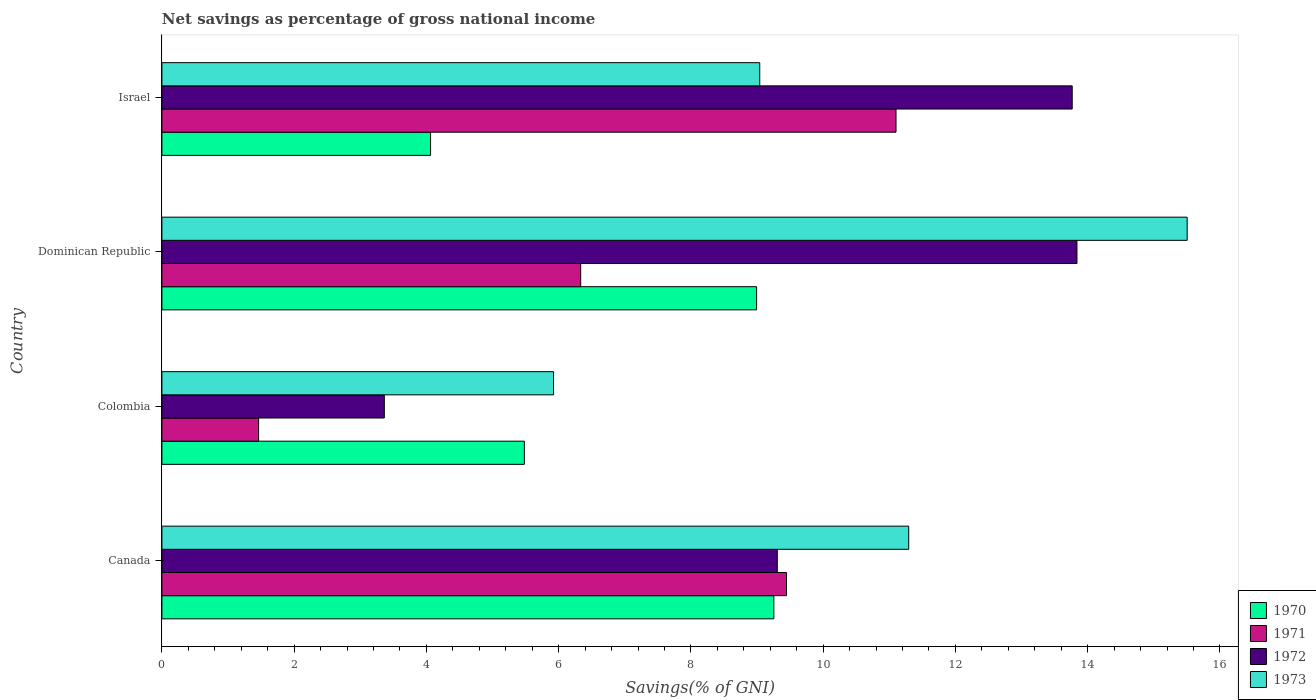How many different coloured bars are there?
Give a very brief answer. 4. How many groups of bars are there?
Give a very brief answer. 4. What is the label of the 4th group of bars from the top?
Keep it short and to the point. Canada. In how many cases, is the number of bars for a given country not equal to the number of legend labels?
Make the answer very short. 0. What is the total savings in 1971 in Canada?
Your response must be concise. 9.45. Across all countries, what is the maximum total savings in 1970?
Offer a terse response. 9.25. Across all countries, what is the minimum total savings in 1971?
Provide a succinct answer. 1.46. In which country was the total savings in 1970 maximum?
Your answer should be very brief. Canada. In which country was the total savings in 1970 minimum?
Offer a very short reply. Israel. What is the total total savings in 1970 in the graph?
Give a very brief answer. 27.79. What is the difference between the total savings in 1972 in Canada and that in Israel?
Provide a succinct answer. -4.46. What is the difference between the total savings in 1970 in Colombia and the total savings in 1971 in Canada?
Offer a very short reply. -3.96. What is the average total savings in 1971 per country?
Your response must be concise. 7.09. What is the difference between the total savings in 1972 and total savings in 1971 in Colombia?
Provide a short and direct response. 1.9. In how many countries, is the total savings in 1973 greater than 11.6 %?
Offer a very short reply. 1. What is the ratio of the total savings in 1973 in Canada to that in Israel?
Make the answer very short. 1.25. Is the total savings in 1972 in Canada less than that in Israel?
Make the answer very short. Yes. Is the difference between the total savings in 1972 in Canada and Dominican Republic greater than the difference between the total savings in 1971 in Canada and Dominican Republic?
Ensure brevity in your answer.  No. What is the difference between the highest and the second highest total savings in 1972?
Give a very brief answer. 0.07. What is the difference between the highest and the lowest total savings in 1971?
Your answer should be very brief. 9.64. In how many countries, is the total savings in 1972 greater than the average total savings in 1972 taken over all countries?
Keep it short and to the point. 2. Is the sum of the total savings in 1973 in Canada and Israel greater than the maximum total savings in 1971 across all countries?
Offer a terse response. Yes. What does the 3rd bar from the top in Canada represents?
Offer a very short reply. 1971. What does the 1st bar from the bottom in Colombia represents?
Provide a short and direct response. 1970. How many bars are there?
Provide a succinct answer. 16. How many countries are there in the graph?
Ensure brevity in your answer.  4. Are the values on the major ticks of X-axis written in scientific E-notation?
Keep it short and to the point. No. Does the graph contain any zero values?
Provide a short and direct response. No. Where does the legend appear in the graph?
Ensure brevity in your answer.  Bottom right. What is the title of the graph?
Provide a succinct answer. Net savings as percentage of gross national income. What is the label or title of the X-axis?
Your answer should be very brief. Savings(% of GNI). What is the Savings(% of GNI) in 1970 in Canada?
Offer a very short reply. 9.25. What is the Savings(% of GNI) of 1971 in Canada?
Offer a very short reply. 9.45. What is the Savings(% of GNI) of 1972 in Canada?
Provide a short and direct response. 9.31. What is the Savings(% of GNI) of 1973 in Canada?
Offer a very short reply. 11.29. What is the Savings(% of GNI) in 1970 in Colombia?
Offer a very short reply. 5.48. What is the Savings(% of GNI) of 1971 in Colombia?
Offer a very short reply. 1.46. What is the Savings(% of GNI) of 1972 in Colombia?
Give a very brief answer. 3.36. What is the Savings(% of GNI) in 1973 in Colombia?
Your answer should be compact. 5.92. What is the Savings(% of GNI) in 1970 in Dominican Republic?
Ensure brevity in your answer.  8.99. What is the Savings(% of GNI) of 1971 in Dominican Republic?
Provide a succinct answer. 6.33. What is the Savings(% of GNI) in 1972 in Dominican Republic?
Ensure brevity in your answer.  13.84. What is the Savings(% of GNI) in 1973 in Dominican Republic?
Offer a very short reply. 15.5. What is the Savings(% of GNI) in 1970 in Israel?
Offer a very short reply. 4.06. What is the Savings(% of GNI) of 1971 in Israel?
Your answer should be very brief. 11.1. What is the Savings(% of GNI) in 1972 in Israel?
Provide a succinct answer. 13.77. What is the Savings(% of GNI) in 1973 in Israel?
Offer a very short reply. 9.04. Across all countries, what is the maximum Savings(% of GNI) of 1970?
Your answer should be very brief. 9.25. Across all countries, what is the maximum Savings(% of GNI) of 1971?
Keep it short and to the point. 11.1. Across all countries, what is the maximum Savings(% of GNI) of 1972?
Your answer should be compact. 13.84. Across all countries, what is the maximum Savings(% of GNI) of 1973?
Provide a succinct answer. 15.5. Across all countries, what is the minimum Savings(% of GNI) of 1970?
Your response must be concise. 4.06. Across all countries, what is the minimum Savings(% of GNI) in 1971?
Your response must be concise. 1.46. Across all countries, what is the minimum Savings(% of GNI) of 1972?
Keep it short and to the point. 3.36. Across all countries, what is the minimum Savings(% of GNI) in 1973?
Offer a terse response. 5.92. What is the total Savings(% of GNI) in 1970 in the graph?
Make the answer very short. 27.79. What is the total Savings(% of GNI) of 1971 in the graph?
Give a very brief answer. 28.34. What is the total Savings(% of GNI) in 1972 in the graph?
Keep it short and to the point. 40.27. What is the total Savings(% of GNI) in 1973 in the graph?
Ensure brevity in your answer.  41.76. What is the difference between the Savings(% of GNI) in 1970 in Canada and that in Colombia?
Your answer should be very brief. 3.77. What is the difference between the Savings(% of GNI) of 1971 in Canada and that in Colombia?
Keep it short and to the point. 7.98. What is the difference between the Savings(% of GNI) in 1972 in Canada and that in Colombia?
Your answer should be compact. 5.94. What is the difference between the Savings(% of GNI) in 1973 in Canada and that in Colombia?
Give a very brief answer. 5.37. What is the difference between the Savings(% of GNI) of 1970 in Canada and that in Dominican Republic?
Keep it short and to the point. 0.26. What is the difference between the Savings(% of GNI) of 1971 in Canada and that in Dominican Republic?
Provide a short and direct response. 3.11. What is the difference between the Savings(% of GNI) of 1972 in Canada and that in Dominican Republic?
Offer a terse response. -4.53. What is the difference between the Savings(% of GNI) of 1973 in Canada and that in Dominican Republic?
Make the answer very short. -4.21. What is the difference between the Savings(% of GNI) of 1970 in Canada and that in Israel?
Your answer should be very brief. 5.19. What is the difference between the Savings(% of GNI) of 1971 in Canada and that in Israel?
Give a very brief answer. -1.66. What is the difference between the Savings(% of GNI) in 1972 in Canada and that in Israel?
Offer a very short reply. -4.46. What is the difference between the Savings(% of GNI) of 1973 in Canada and that in Israel?
Offer a very short reply. 2.25. What is the difference between the Savings(% of GNI) of 1970 in Colombia and that in Dominican Republic?
Provide a succinct answer. -3.51. What is the difference between the Savings(% of GNI) of 1971 in Colombia and that in Dominican Republic?
Offer a terse response. -4.87. What is the difference between the Savings(% of GNI) of 1972 in Colombia and that in Dominican Republic?
Provide a short and direct response. -10.47. What is the difference between the Savings(% of GNI) in 1973 in Colombia and that in Dominican Republic?
Your answer should be very brief. -9.58. What is the difference between the Savings(% of GNI) of 1970 in Colombia and that in Israel?
Give a very brief answer. 1.42. What is the difference between the Savings(% of GNI) in 1971 in Colombia and that in Israel?
Offer a very short reply. -9.64. What is the difference between the Savings(% of GNI) in 1972 in Colombia and that in Israel?
Keep it short and to the point. -10.4. What is the difference between the Savings(% of GNI) in 1973 in Colombia and that in Israel?
Your answer should be very brief. -3.12. What is the difference between the Savings(% of GNI) of 1970 in Dominican Republic and that in Israel?
Make the answer very short. 4.93. What is the difference between the Savings(% of GNI) of 1971 in Dominican Republic and that in Israel?
Ensure brevity in your answer.  -4.77. What is the difference between the Savings(% of GNI) in 1972 in Dominican Republic and that in Israel?
Ensure brevity in your answer.  0.07. What is the difference between the Savings(% of GNI) of 1973 in Dominican Republic and that in Israel?
Offer a very short reply. 6.46. What is the difference between the Savings(% of GNI) in 1970 in Canada and the Savings(% of GNI) in 1971 in Colombia?
Offer a terse response. 7.79. What is the difference between the Savings(% of GNI) of 1970 in Canada and the Savings(% of GNI) of 1972 in Colombia?
Provide a succinct answer. 5.89. What is the difference between the Savings(% of GNI) of 1970 in Canada and the Savings(% of GNI) of 1973 in Colombia?
Give a very brief answer. 3.33. What is the difference between the Savings(% of GNI) in 1971 in Canada and the Savings(% of GNI) in 1972 in Colombia?
Your answer should be very brief. 6.08. What is the difference between the Savings(% of GNI) of 1971 in Canada and the Savings(% of GNI) of 1973 in Colombia?
Your answer should be compact. 3.52. What is the difference between the Savings(% of GNI) of 1972 in Canada and the Savings(% of GNI) of 1973 in Colombia?
Your response must be concise. 3.38. What is the difference between the Savings(% of GNI) in 1970 in Canada and the Savings(% of GNI) in 1971 in Dominican Republic?
Offer a very short reply. 2.92. What is the difference between the Savings(% of GNI) in 1970 in Canada and the Savings(% of GNI) in 1972 in Dominican Republic?
Ensure brevity in your answer.  -4.58. What is the difference between the Savings(% of GNI) of 1970 in Canada and the Savings(% of GNI) of 1973 in Dominican Republic?
Keep it short and to the point. -6.25. What is the difference between the Savings(% of GNI) in 1971 in Canada and the Savings(% of GNI) in 1972 in Dominican Republic?
Your answer should be very brief. -4.39. What is the difference between the Savings(% of GNI) in 1971 in Canada and the Savings(% of GNI) in 1973 in Dominican Republic?
Your answer should be very brief. -6.06. What is the difference between the Savings(% of GNI) in 1972 in Canada and the Savings(% of GNI) in 1973 in Dominican Republic?
Your answer should be compact. -6.2. What is the difference between the Savings(% of GNI) in 1970 in Canada and the Savings(% of GNI) in 1971 in Israel?
Your answer should be very brief. -1.85. What is the difference between the Savings(% of GNI) in 1970 in Canada and the Savings(% of GNI) in 1972 in Israel?
Keep it short and to the point. -4.51. What is the difference between the Savings(% of GNI) of 1970 in Canada and the Savings(% of GNI) of 1973 in Israel?
Your answer should be compact. 0.21. What is the difference between the Savings(% of GNI) in 1971 in Canada and the Savings(% of GNI) in 1972 in Israel?
Your response must be concise. -4.32. What is the difference between the Savings(% of GNI) of 1971 in Canada and the Savings(% of GNI) of 1973 in Israel?
Make the answer very short. 0.4. What is the difference between the Savings(% of GNI) in 1972 in Canada and the Savings(% of GNI) in 1973 in Israel?
Your answer should be very brief. 0.27. What is the difference between the Savings(% of GNI) in 1970 in Colombia and the Savings(% of GNI) in 1971 in Dominican Republic?
Your answer should be compact. -0.85. What is the difference between the Savings(% of GNI) of 1970 in Colombia and the Savings(% of GNI) of 1972 in Dominican Republic?
Offer a very short reply. -8.36. What is the difference between the Savings(% of GNI) of 1970 in Colombia and the Savings(% of GNI) of 1973 in Dominican Republic?
Ensure brevity in your answer.  -10.02. What is the difference between the Savings(% of GNI) in 1971 in Colombia and the Savings(% of GNI) in 1972 in Dominican Republic?
Make the answer very short. -12.38. What is the difference between the Savings(% of GNI) of 1971 in Colombia and the Savings(% of GNI) of 1973 in Dominican Republic?
Make the answer very short. -14.04. What is the difference between the Savings(% of GNI) of 1972 in Colombia and the Savings(% of GNI) of 1973 in Dominican Republic?
Ensure brevity in your answer.  -12.14. What is the difference between the Savings(% of GNI) of 1970 in Colombia and the Savings(% of GNI) of 1971 in Israel?
Give a very brief answer. -5.62. What is the difference between the Savings(% of GNI) of 1970 in Colombia and the Savings(% of GNI) of 1972 in Israel?
Ensure brevity in your answer.  -8.28. What is the difference between the Savings(% of GNI) in 1970 in Colombia and the Savings(% of GNI) in 1973 in Israel?
Make the answer very short. -3.56. What is the difference between the Savings(% of GNI) in 1971 in Colombia and the Savings(% of GNI) in 1972 in Israel?
Provide a succinct answer. -12.3. What is the difference between the Savings(% of GNI) of 1971 in Colombia and the Savings(% of GNI) of 1973 in Israel?
Provide a succinct answer. -7.58. What is the difference between the Savings(% of GNI) of 1972 in Colombia and the Savings(% of GNI) of 1973 in Israel?
Provide a short and direct response. -5.68. What is the difference between the Savings(% of GNI) in 1970 in Dominican Republic and the Savings(% of GNI) in 1971 in Israel?
Keep it short and to the point. -2.11. What is the difference between the Savings(% of GNI) in 1970 in Dominican Republic and the Savings(% of GNI) in 1972 in Israel?
Your response must be concise. -4.77. What is the difference between the Savings(% of GNI) of 1970 in Dominican Republic and the Savings(% of GNI) of 1973 in Israel?
Your answer should be compact. -0.05. What is the difference between the Savings(% of GNI) of 1971 in Dominican Republic and the Savings(% of GNI) of 1972 in Israel?
Provide a succinct answer. -7.43. What is the difference between the Savings(% of GNI) of 1971 in Dominican Republic and the Savings(% of GNI) of 1973 in Israel?
Your response must be concise. -2.71. What is the difference between the Savings(% of GNI) of 1972 in Dominican Republic and the Savings(% of GNI) of 1973 in Israel?
Offer a very short reply. 4.8. What is the average Savings(% of GNI) of 1970 per country?
Keep it short and to the point. 6.95. What is the average Savings(% of GNI) in 1971 per country?
Give a very brief answer. 7.09. What is the average Savings(% of GNI) in 1972 per country?
Keep it short and to the point. 10.07. What is the average Savings(% of GNI) in 1973 per country?
Ensure brevity in your answer.  10.44. What is the difference between the Savings(% of GNI) in 1970 and Savings(% of GNI) in 1971 in Canada?
Make the answer very short. -0.19. What is the difference between the Savings(% of GNI) of 1970 and Savings(% of GNI) of 1972 in Canada?
Ensure brevity in your answer.  -0.05. What is the difference between the Savings(% of GNI) in 1970 and Savings(% of GNI) in 1973 in Canada?
Your answer should be compact. -2.04. What is the difference between the Savings(% of GNI) in 1971 and Savings(% of GNI) in 1972 in Canada?
Offer a very short reply. 0.14. What is the difference between the Savings(% of GNI) of 1971 and Savings(% of GNI) of 1973 in Canada?
Keep it short and to the point. -1.85. What is the difference between the Savings(% of GNI) in 1972 and Savings(% of GNI) in 1973 in Canada?
Your response must be concise. -1.99. What is the difference between the Savings(% of GNI) of 1970 and Savings(% of GNI) of 1971 in Colombia?
Offer a very short reply. 4.02. What is the difference between the Savings(% of GNI) in 1970 and Savings(% of GNI) in 1972 in Colombia?
Make the answer very short. 2.12. What is the difference between the Savings(% of GNI) in 1970 and Savings(% of GNI) in 1973 in Colombia?
Your response must be concise. -0.44. What is the difference between the Savings(% of GNI) of 1971 and Savings(% of GNI) of 1972 in Colombia?
Offer a very short reply. -1.9. What is the difference between the Savings(% of GNI) of 1971 and Savings(% of GNI) of 1973 in Colombia?
Offer a very short reply. -4.46. What is the difference between the Savings(% of GNI) of 1972 and Savings(% of GNI) of 1973 in Colombia?
Your answer should be compact. -2.56. What is the difference between the Savings(% of GNI) of 1970 and Savings(% of GNI) of 1971 in Dominican Republic?
Your answer should be very brief. 2.66. What is the difference between the Savings(% of GNI) in 1970 and Savings(% of GNI) in 1972 in Dominican Republic?
Your answer should be compact. -4.84. What is the difference between the Savings(% of GNI) of 1970 and Savings(% of GNI) of 1973 in Dominican Republic?
Give a very brief answer. -6.51. What is the difference between the Savings(% of GNI) in 1971 and Savings(% of GNI) in 1972 in Dominican Republic?
Provide a succinct answer. -7.5. What is the difference between the Savings(% of GNI) of 1971 and Savings(% of GNI) of 1973 in Dominican Republic?
Offer a terse response. -9.17. What is the difference between the Savings(% of GNI) in 1972 and Savings(% of GNI) in 1973 in Dominican Republic?
Offer a very short reply. -1.67. What is the difference between the Savings(% of GNI) of 1970 and Savings(% of GNI) of 1971 in Israel?
Keep it short and to the point. -7.04. What is the difference between the Savings(% of GNI) in 1970 and Savings(% of GNI) in 1972 in Israel?
Keep it short and to the point. -9.7. What is the difference between the Savings(% of GNI) of 1970 and Savings(% of GNI) of 1973 in Israel?
Offer a very short reply. -4.98. What is the difference between the Savings(% of GNI) in 1971 and Savings(% of GNI) in 1972 in Israel?
Give a very brief answer. -2.66. What is the difference between the Savings(% of GNI) of 1971 and Savings(% of GNI) of 1973 in Israel?
Give a very brief answer. 2.06. What is the difference between the Savings(% of GNI) in 1972 and Savings(% of GNI) in 1973 in Israel?
Provide a succinct answer. 4.73. What is the ratio of the Savings(% of GNI) in 1970 in Canada to that in Colombia?
Provide a short and direct response. 1.69. What is the ratio of the Savings(% of GNI) of 1971 in Canada to that in Colombia?
Offer a terse response. 6.46. What is the ratio of the Savings(% of GNI) in 1972 in Canada to that in Colombia?
Offer a terse response. 2.77. What is the ratio of the Savings(% of GNI) in 1973 in Canada to that in Colombia?
Your answer should be compact. 1.91. What is the ratio of the Savings(% of GNI) in 1970 in Canada to that in Dominican Republic?
Keep it short and to the point. 1.03. What is the ratio of the Savings(% of GNI) of 1971 in Canada to that in Dominican Republic?
Make the answer very short. 1.49. What is the ratio of the Savings(% of GNI) of 1972 in Canada to that in Dominican Republic?
Ensure brevity in your answer.  0.67. What is the ratio of the Savings(% of GNI) of 1973 in Canada to that in Dominican Republic?
Provide a short and direct response. 0.73. What is the ratio of the Savings(% of GNI) of 1970 in Canada to that in Israel?
Your answer should be compact. 2.28. What is the ratio of the Savings(% of GNI) of 1971 in Canada to that in Israel?
Your answer should be compact. 0.85. What is the ratio of the Savings(% of GNI) of 1972 in Canada to that in Israel?
Give a very brief answer. 0.68. What is the ratio of the Savings(% of GNI) of 1973 in Canada to that in Israel?
Provide a succinct answer. 1.25. What is the ratio of the Savings(% of GNI) in 1970 in Colombia to that in Dominican Republic?
Your answer should be very brief. 0.61. What is the ratio of the Savings(% of GNI) of 1971 in Colombia to that in Dominican Republic?
Make the answer very short. 0.23. What is the ratio of the Savings(% of GNI) of 1972 in Colombia to that in Dominican Republic?
Give a very brief answer. 0.24. What is the ratio of the Savings(% of GNI) of 1973 in Colombia to that in Dominican Republic?
Your answer should be compact. 0.38. What is the ratio of the Savings(% of GNI) in 1970 in Colombia to that in Israel?
Keep it short and to the point. 1.35. What is the ratio of the Savings(% of GNI) of 1971 in Colombia to that in Israel?
Your answer should be compact. 0.13. What is the ratio of the Savings(% of GNI) in 1972 in Colombia to that in Israel?
Make the answer very short. 0.24. What is the ratio of the Savings(% of GNI) of 1973 in Colombia to that in Israel?
Provide a short and direct response. 0.66. What is the ratio of the Savings(% of GNI) of 1970 in Dominican Republic to that in Israel?
Provide a short and direct response. 2.21. What is the ratio of the Savings(% of GNI) of 1971 in Dominican Republic to that in Israel?
Make the answer very short. 0.57. What is the ratio of the Savings(% of GNI) of 1973 in Dominican Republic to that in Israel?
Offer a very short reply. 1.71. What is the difference between the highest and the second highest Savings(% of GNI) in 1970?
Your answer should be very brief. 0.26. What is the difference between the highest and the second highest Savings(% of GNI) in 1971?
Offer a terse response. 1.66. What is the difference between the highest and the second highest Savings(% of GNI) in 1972?
Make the answer very short. 0.07. What is the difference between the highest and the second highest Savings(% of GNI) of 1973?
Your answer should be very brief. 4.21. What is the difference between the highest and the lowest Savings(% of GNI) in 1970?
Offer a very short reply. 5.19. What is the difference between the highest and the lowest Savings(% of GNI) in 1971?
Give a very brief answer. 9.64. What is the difference between the highest and the lowest Savings(% of GNI) of 1972?
Make the answer very short. 10.47. What is the difference between the highest and the lowest Savings(% of GNI) in 1973?
Give a very brief answer. 9.58. 